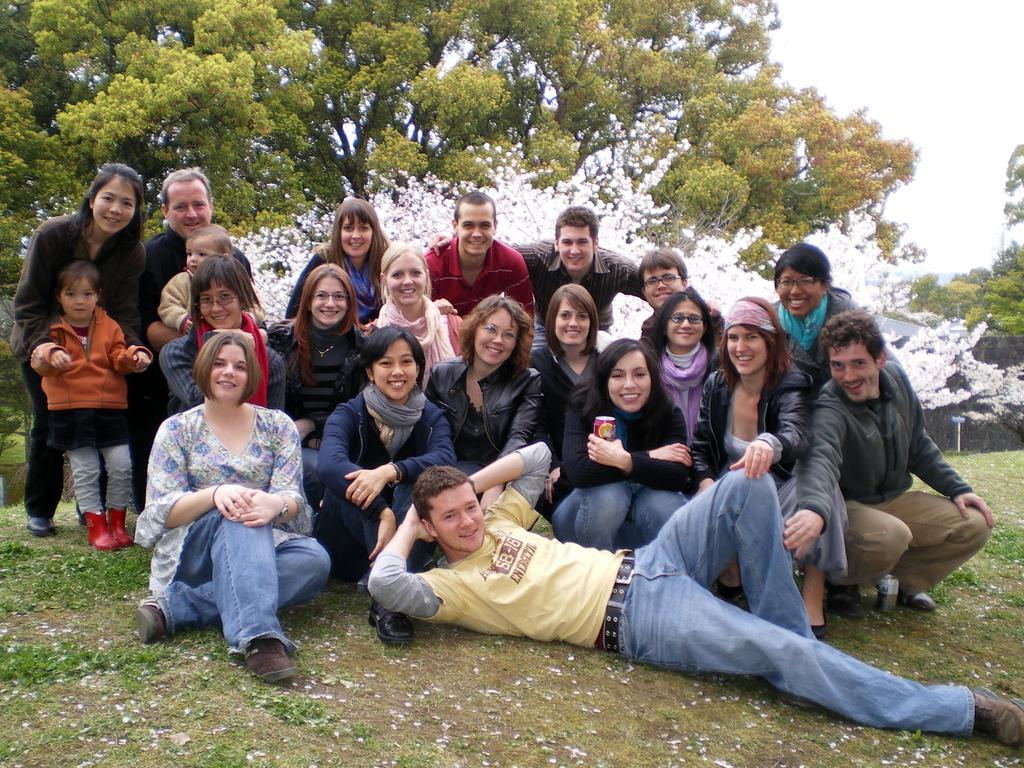What are the people in the image doing? There are persons sitting, a girl is standing, and a man is lying in the image. Are there any other positions that people are in? Yes, there are persons in a squat position on the ground. What can be seen in the background of the image? There are trees and the sky visible in the background of the image. What type of pin can be seen holding the girl's dress in the image? There is no pin visible in the image, and the girl's dress is not being held by any pin. 